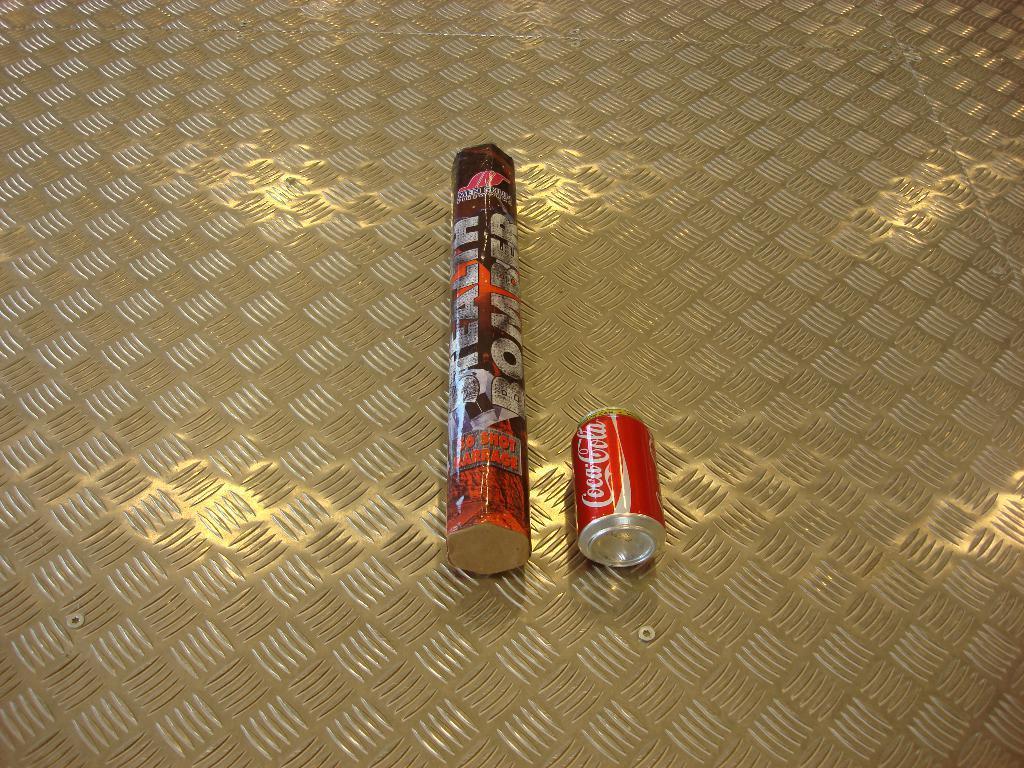Describe this image in one or two sentences. In this image there are two objects. At the right side there is a can with the text Coca-Cola, and in the center there is a paper with text printed on it. 